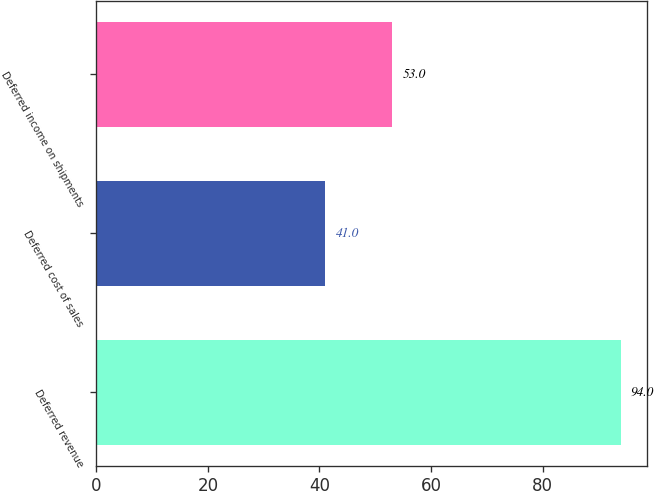Convert chart to OTSL. <chart><loc_0><loc_0><loc_500><loc_500><bar_chart><fcel>Deferred revenue<fcel>Deferred cost of sales<fcel>Deferred income on shipments<nl><fcel>94<fcel>41<fcel>53<nl></chart> 